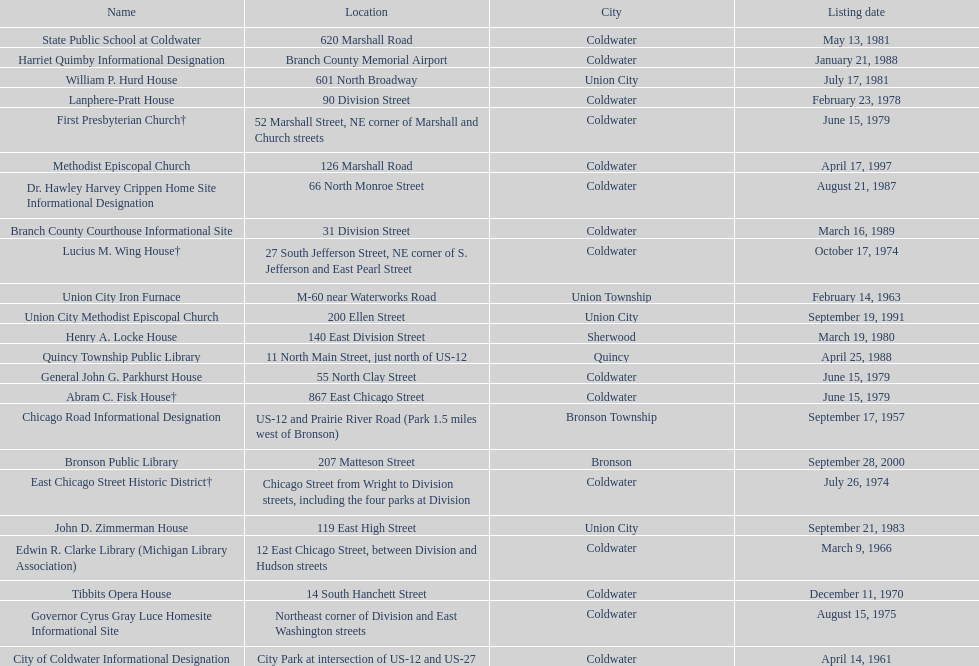What is the overall number of names currently listed on this chart? 23. 